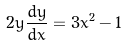Convert formula to latex. <formula><loc_0><loc_0><loc_500><loc_500>2 y \frac { d y } { d x } = 3 x ^ { 2 } - 1</formula> 